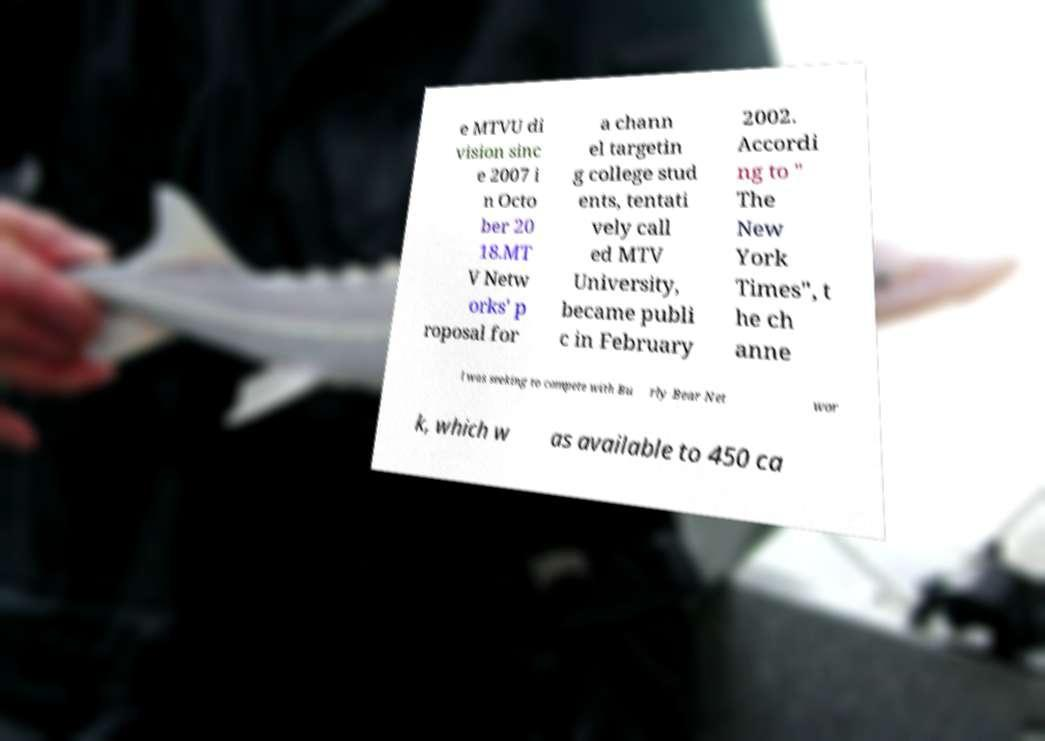I need the written content from this picture converted into text. Can you do that? e MTVU di vision sinc e 2007 i n Octo ber 20 18.MT V Netw orks' p roposal for a chann el targetin g college stud ents, tentati vely call ed MTV University, became publi c in February 2002. Accordi ng to " The New York Times", t he ch anne l was seeking to compete with Bu rly Bear Net wor k, which w as available to 450 ca 